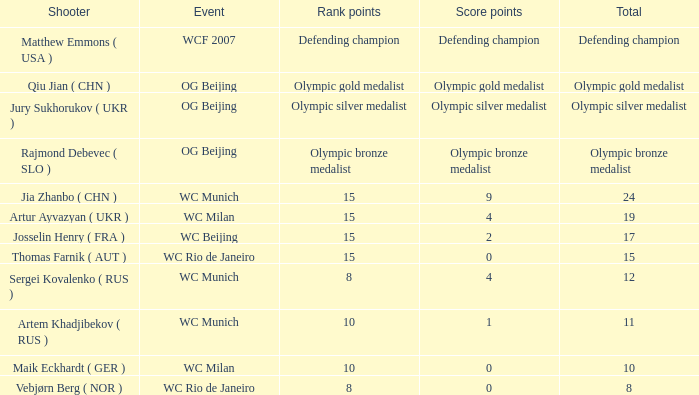When the sum is 11, what are the score points? 1.0. 